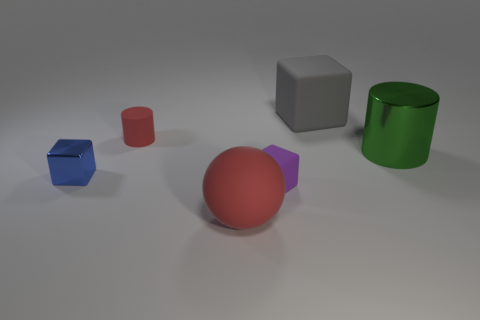Are there any other things of the same color as the big metallic cylinder?
Your answer should be very brief. No. There is a metal cylinder that is to the right of the big gray rubber block; what number of cylinders are behind it?
Give a very brief answer. 1. What is the material of the big gray block?
Offer a terse response. Rubber. How many red objects are behind the large red rubber ball?
Keep it short and to the point. 1. Is the big rubber sphere the same color as the tiny cylinder?
Provide a short and direct response. Yes. How many big balls are the same color as the large cube?
Keep it short and to the point. 0. Is the number of small cylinders greater than the number of brown cylinders?
Offer a very short reply. Yes. What size is the thing that is both left of the big green cylinder and to the right of the purple cube?
Provide a short and direct response. Large. Are the object that is left of the tiny red cylinder and the red thing that is in front of the small purple block made of the same material?
Your answer should be compact. No. What shape is the red object that is the same size as the green cylinder?
Provide a succinct answer. Sphere. 